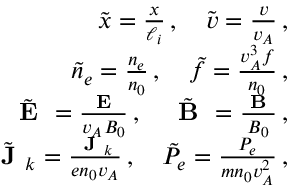<formula> <loc_0><loc_0><loc_500><loc_500>\begin{array} { r l r } & { \tilde { x } = \frac { x } { \ell _ { i } } \, , \quad \tilde { v } = \frac { v } { v _ { A } } \, , } \\ & { \tilde { n } _ { e } = \frac { n _ { e } } { n _ { 0 } } \, , \quad \tilde { f } = \frac { v _ { A } ^ { 3 } f } { n _ { 0 } } \, , } \\ & { \tilde { E } = \frac { E } { v _ { A } B _ { 0 } } \, , \quad \tilde { B } = \frac { B } { B _ { 0 } } \, , } \\ & { \tilde { J } _ { k } = \frac { J _ { k } } { e n _ { 0 } v _ { A } } \, , \quad \tilde { P } _ { e } = \frac { P _ { e } } { m n _ { 0 } v _ { A } ^ { 2 } } \, , } \end{array}</formula> 